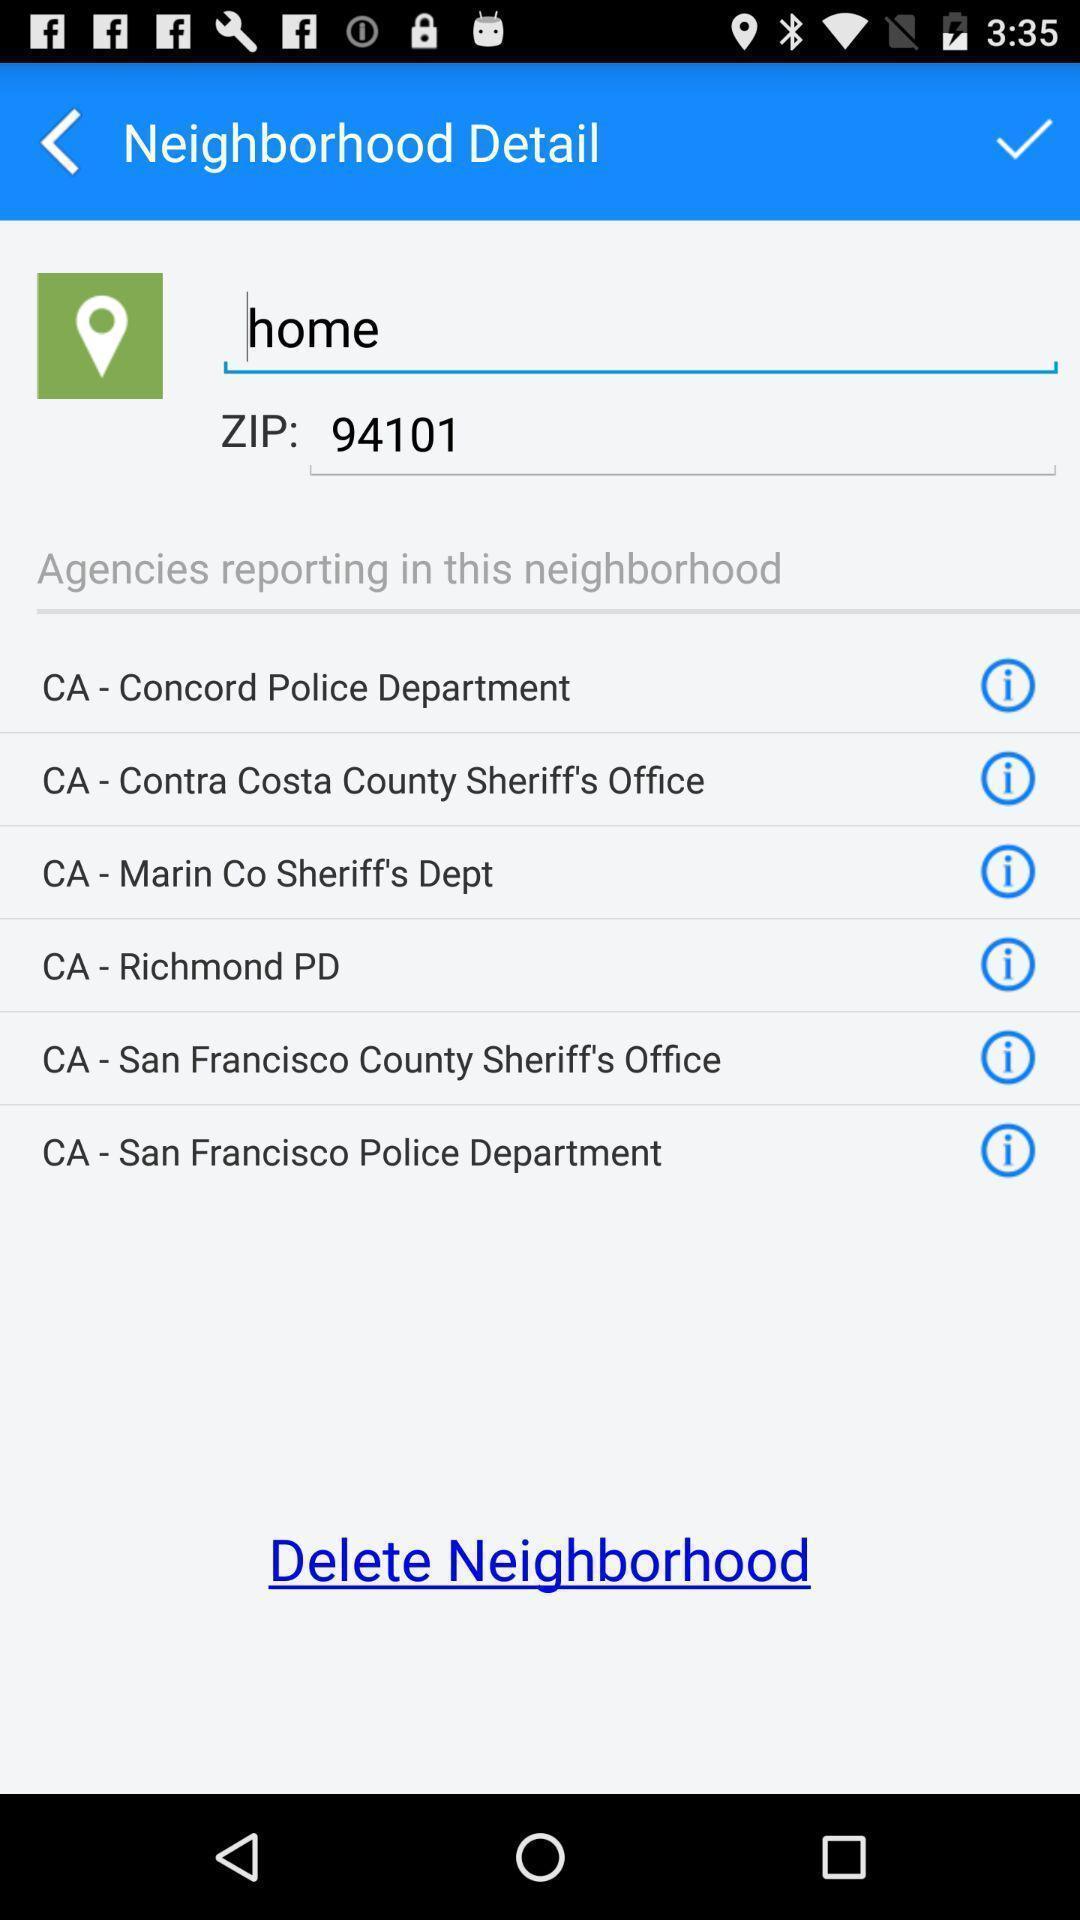Provide a textual representation of this image. Screen showing neighborhood details with list of agencies. 